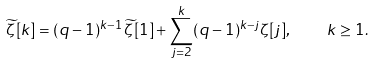Convert formula to latex. <formula><loc_0><loc_0><loc_500><loc_500>\widetilde { \zeta } [ k ] = ( q - 1 ) ^ { k - 1 } \, \widetilde { \zeta } [ 1 ] + \sum _ { j = 2 } ^ { k } ( q - 1 ) ^ { k - j } \zeta [ j ] , \quad k \geq 1 .</formula> 